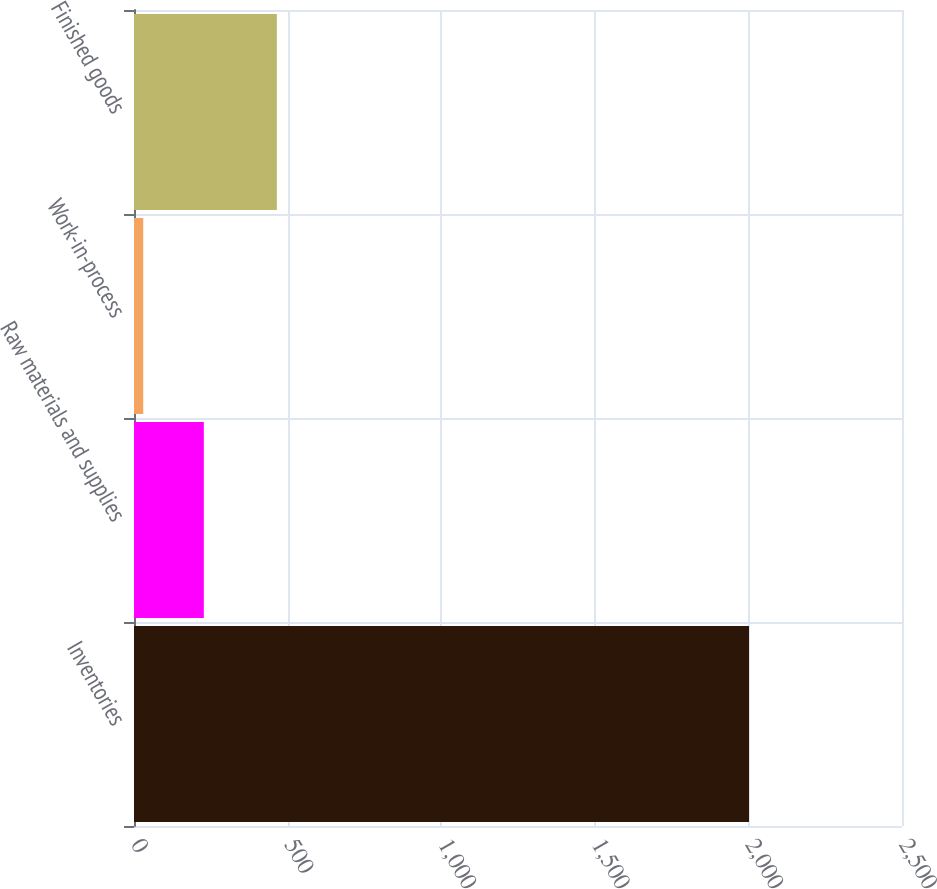Convert chart to OTSL. <chart><loc_0><loc_0><loc_500><loc_500><bar_chart><fcel>Inventories<fcel>Raw materials and supplies<fcel>Work-in-process<fcel>Finished goods<nl><fcel>2002<fcel>227.29<fcel>30.1<fcel>465<nl></chart> 